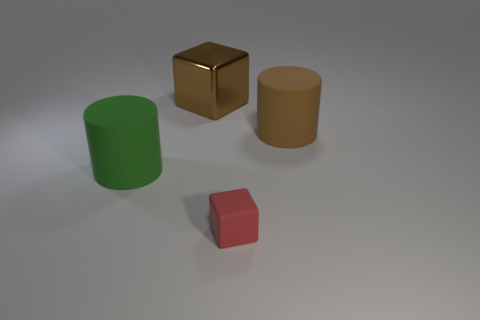There is a matte cylinder that is on the right side of the big matte cylinder that is on the left side of the brown rubber cylinder; what color is it?
Your response must be concise. Brown. What is the shape of the rubber thing that is the same size as the green rubber cylinder?
Your response must be concise. Cylinder. The other big thing that is the same color as the big metallic thing is what shape?
Make the answer very short. Cylinder. Are there an equal number of green matte cylinders in front of the green cylinder and small red blocks?
Provide a short and direct response. No. There is a block that is behind the big rubber thing in front of the big matte cylinder that is right of the big metal block; what is its material?
Make the answer very short. Metal. What shape is the small thing that is the same material as the green cylinder?
Ensure brevity in your answer.  Cube. Are there any other things that are the same color as the shiny object?
Give a very brief answer. Yes. There is a cube that is in front of the large cylinder that is to the right of the red matte object; what number of cylinders are to the right of it?
Your answer should be very brief. 1. How many red objects are tiny things or big metal blocks?
Offer a terse response. 1. There is a brown metallic cube; is it the same size as the thing on the right side of the matte block?
Offer a terse response. Yes. 